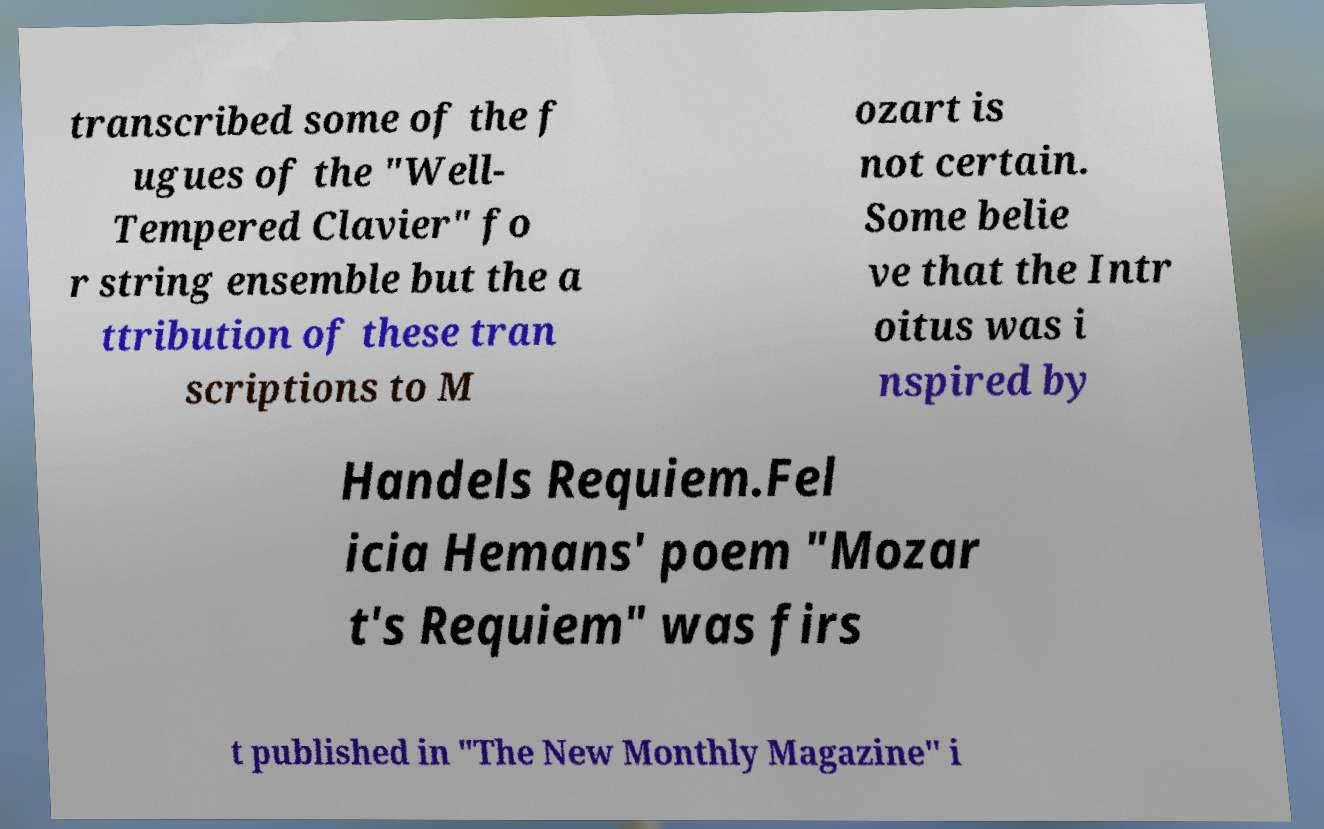For documentation purposes, I need the text within this image transcribed. Could you provide that? transcribed some of the f ugues of the "Well- Tempered Clavier" fo r string ensemble but the a ttribution of these tran scriptions to M ozart is not certain. Some belie ve that the Intr oitus was i nspired by Handels Requiem.Fel icia Hemans' poem "Mozar t's Requiem" was firs t published in "The New Monthly Magazine" i 